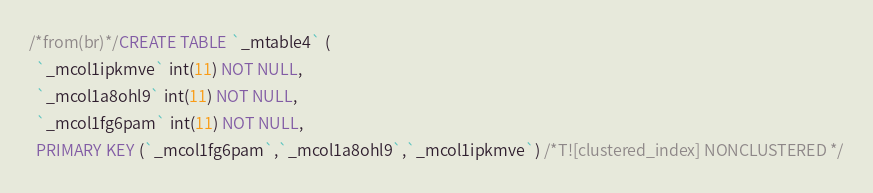Convert code to text. <code><loc_0><loc_0><loc_500><loc_500><_SQL_>/*from(br)*/CREATE TABLE `_mtable4` (
  `_mcol1ipkmve` int(11) NOT NULL,
  `_mcol1a8ohl9` int(11) NOT NULL,
  `_mcol1fg6pam` int(11) NOT NULL,
  PRIMARY KEY (`_mcol1fg6pam`,`_mcol1a8ohl9`,`_mcol1ipkmve`) /*T![clustered_index] NONCLUSTERED */</code> 